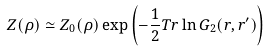Convert formula to latex. <formula><loc_0><loc_0><loc_500><loc_500>Z ( \rho ) \simeq Z _ { 0 } ( \rho ) \exp \left ( - \frac { 1 } { 2 } T r \ln G _ { 2 } ( r , r ^ { \prime } ) \right )</formula> 